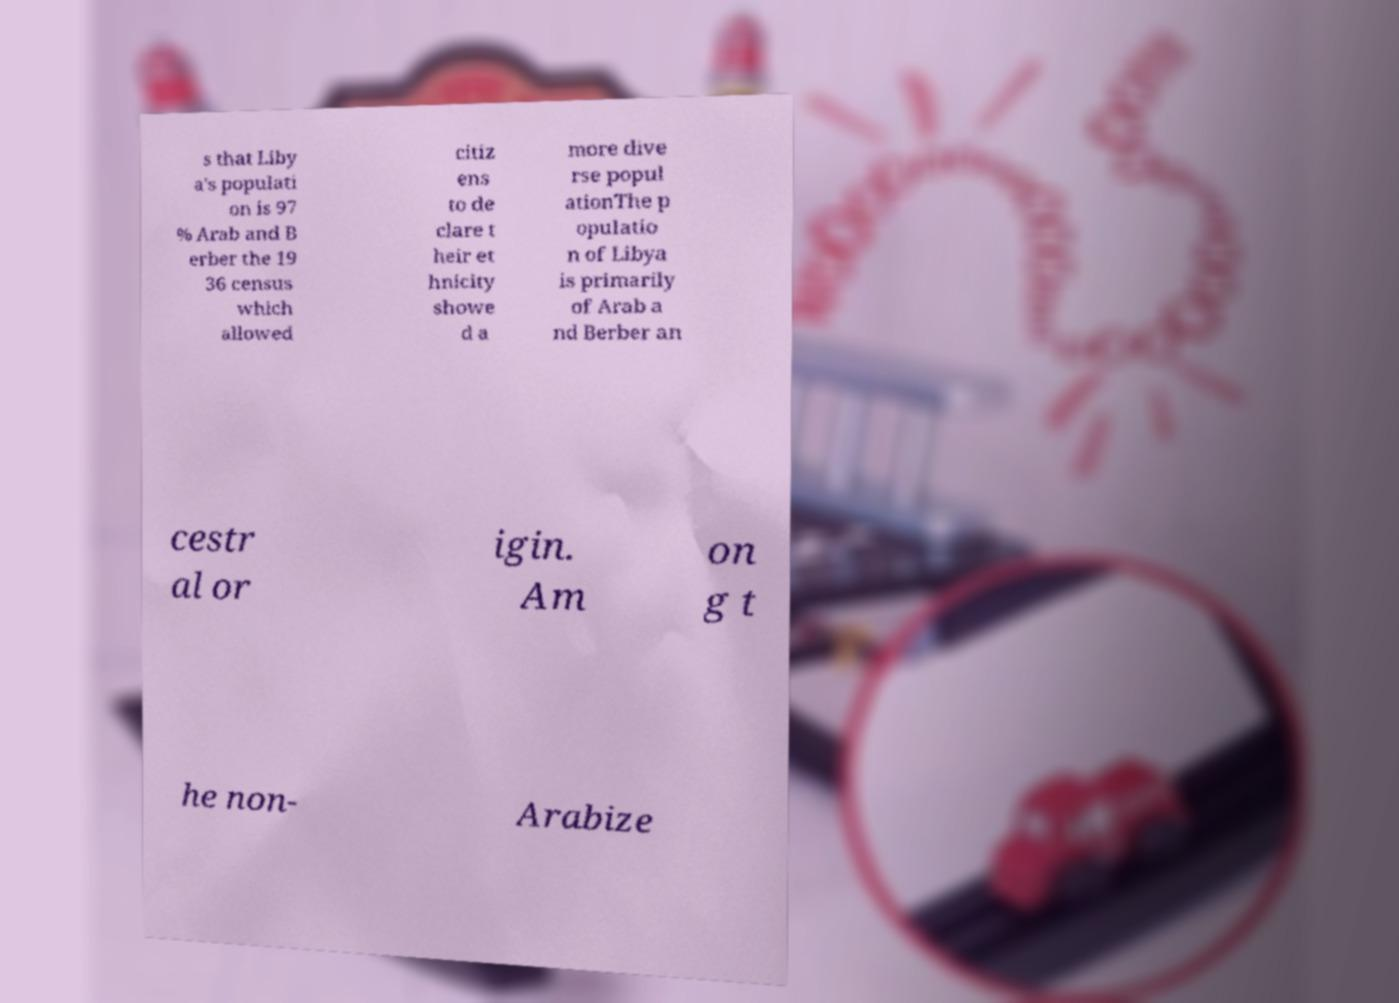I need the written content from this picture converted into text. Can you do that? s that Liby a's populati on is 97 % Arab and B erber the 19 36 census which allowed citiz ens to de clare t heir et hnicity showe d a more dive rse popul ationThe p opulatio n of Libya is primarily of Arab a nd Berber an cestr al or igin. Am on g t he non- Arabize 